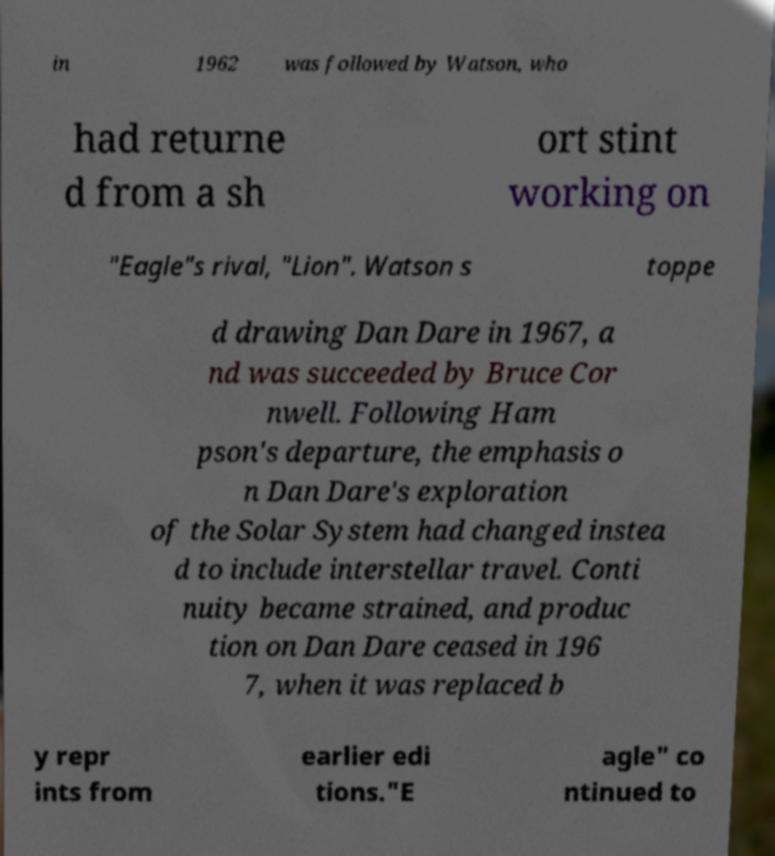For documentation purposes, I need the text within this image transcribed. Could you provide that? in 1962 was followed by Watson, who had returne d from a sh ort stint working on "Eagle"s rival, "Lion". Watson s toppe d drawing Dan Dare in 1967, a nd was succeeded by Bruce Cor nwell. Following Ham pson's departure, the emphasis o n Dan Dare's exploration of the Solar System had changed instea d to include interstellar travel. Conti nuity became strained, and produc tion on Dan Dare ceased in 196 7, when it was replaced b y repr ints from earlier edi tions."E agle" co ntinued to 